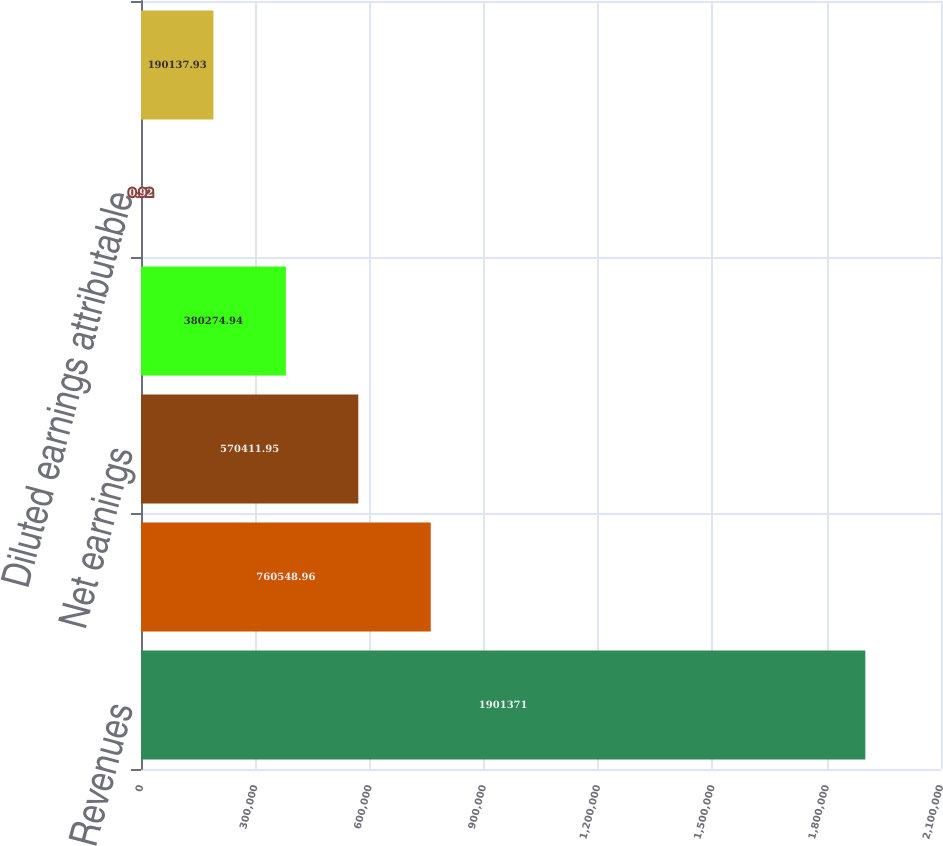<chart> <loc_0><loc_0><loc_500><loc_500><bar_chart><fcel>Revenues<fcel>Net revenues<fcel>Net earnings<fcel>Net earnings attributable to<fcel>Diluted earnings attributable<fcel>Basic earnings attributable to<nl><fcel>1.90137e+06<fcel>760549<fcel>570412<fcel>380275<fcel>0.92<fcel>190138<nl></chart> 